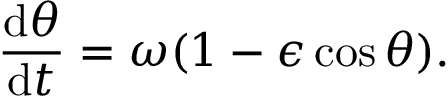<formula> <loc_0><loc_0><loc_500><loc_500>\frac { d \theta } { d t } = \omega ( 1 - \epsilon \cos \theta ) .</formula> 